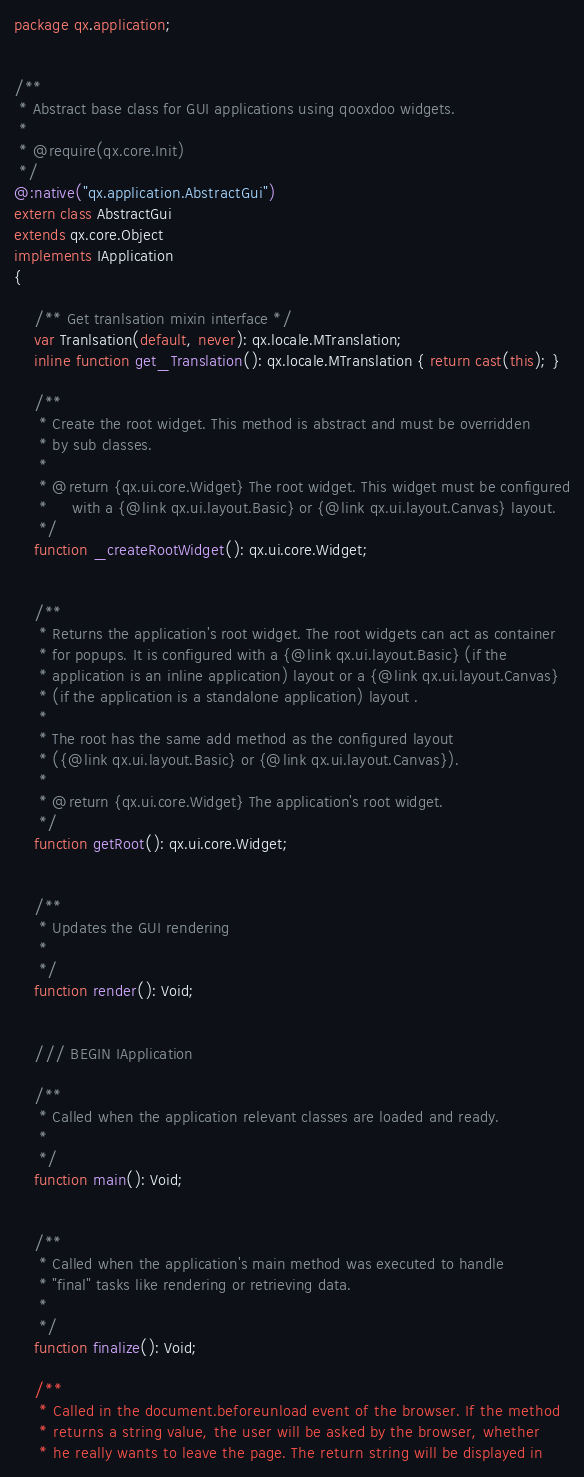Convert code to text. <code><loc_0><loc_0><loc_500><loc_500><_Haxe_>package qx.application;


/**
 * Abstract base class for GUI applications using qooxdoo widgets.
 *
 * @require(qx.core.Init)
 */
@:native("qx.application.AbstractGui")
extern class AbstractGui
extends qx.core.Object
implements IApplication
{

    /** Get tranlsation mixin interface */
    var Tranlsation(default, never): qx.locale.MTranslation;
    inline function get_Translation(): qx.locale.MTranslation { return cast(this); }
	
	/**
     * Create the root widget. This method is abstract and must be overridden
     * by sub classes.
     *
     * @return {qx.ui.core.Widget} The root widget. This widget must be configured
     *     with a {@link qx.ui.layout.Basic} or {@link qx.ui.layout.Canvas} layout.
     */
    function _createRootWidget(): qx.ui.core.Widget;
	
	
	/**
     * Returns the application's root widget. The root widgets can act as container
     * for popups. It is configured with a {@link qx.ui.layout.Basic} (if the
     * application is an inline application) layout or a {@link qx.ui.layout.Canvas}
     * (if the application is a standalone application) layout .
     *
     * The root has the same add method as the configured layout
     * ({@link qx.ui.layout.Basic} or {@link qx.ui.layout.Canvas}).
     *
     * @return {qx.ui.core.Widget} The application's root widget.
     */
    function getRoot(): qx.ui.core.Widget;
	
	
	/**
     * Updates the GUI rendering
     *
     */
    function render(): Void;
	
	
	/// BEGIN IApplication
	
	/**
     * Called when the application relevant classes are loaded and ready.
     *
     */
    function main(): Void;


    /**
     * Called when the application's main method was executed to handle
     * "final" tasks like rendering or retrieving data.
     *
     */
    function finalize(): Void;
	
	/**
     * Called in the document.beforeunload event of the browser. If the method
     * returns a string value, the user will be asked by the browser, whether
     * he really wants to leave the page. The return string will be displayed in</code> 